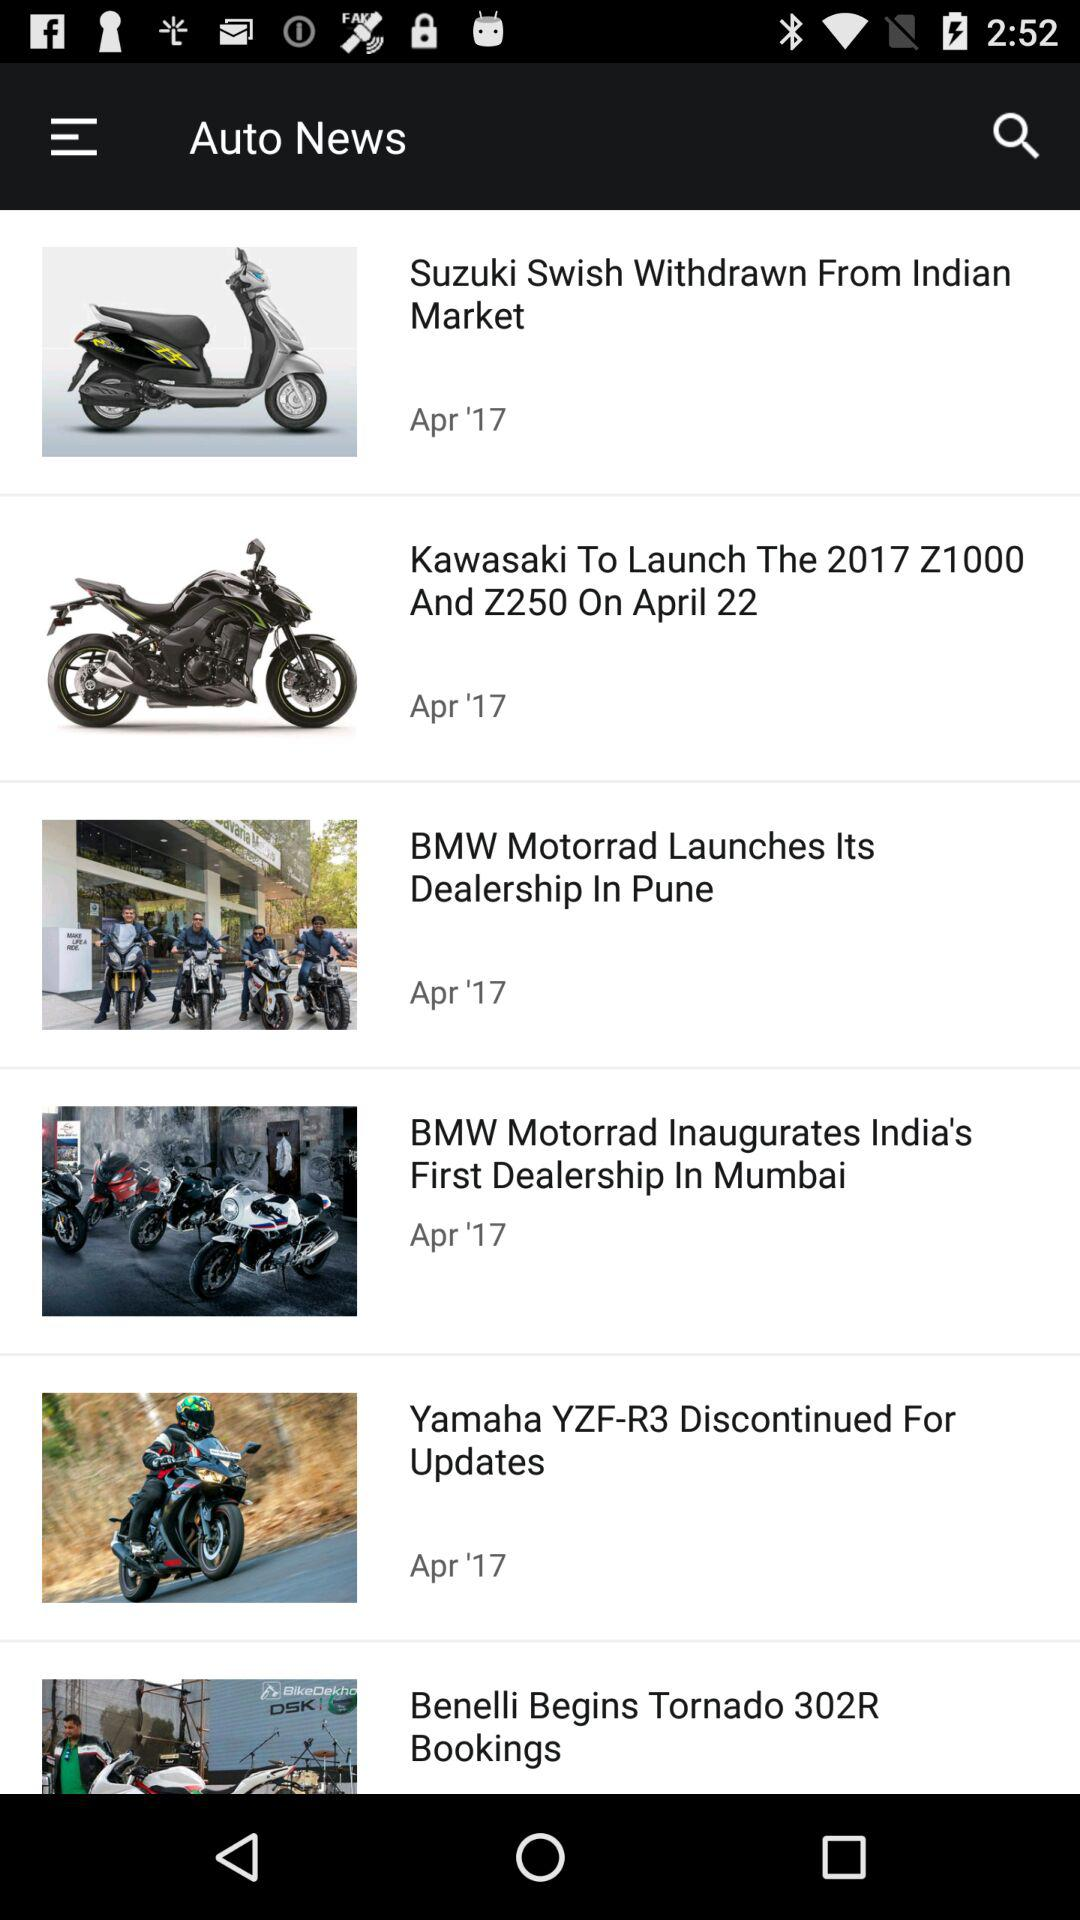What are the available auto news? The available auto news are "Suzuki Swish Withdrawn From Indian Market", "Kawasaki To Launch The 2017 Z1000 And Z250 On April 22", "BMW Motorrad Launches Its Dealership In Pune", "BMW Motorrad Inaugurates India's First Dealership In Mumbai", "Yamaha YZF-R3 Discontinued For Updates" and "Benelli Begins Tornado 302R Bookings". 